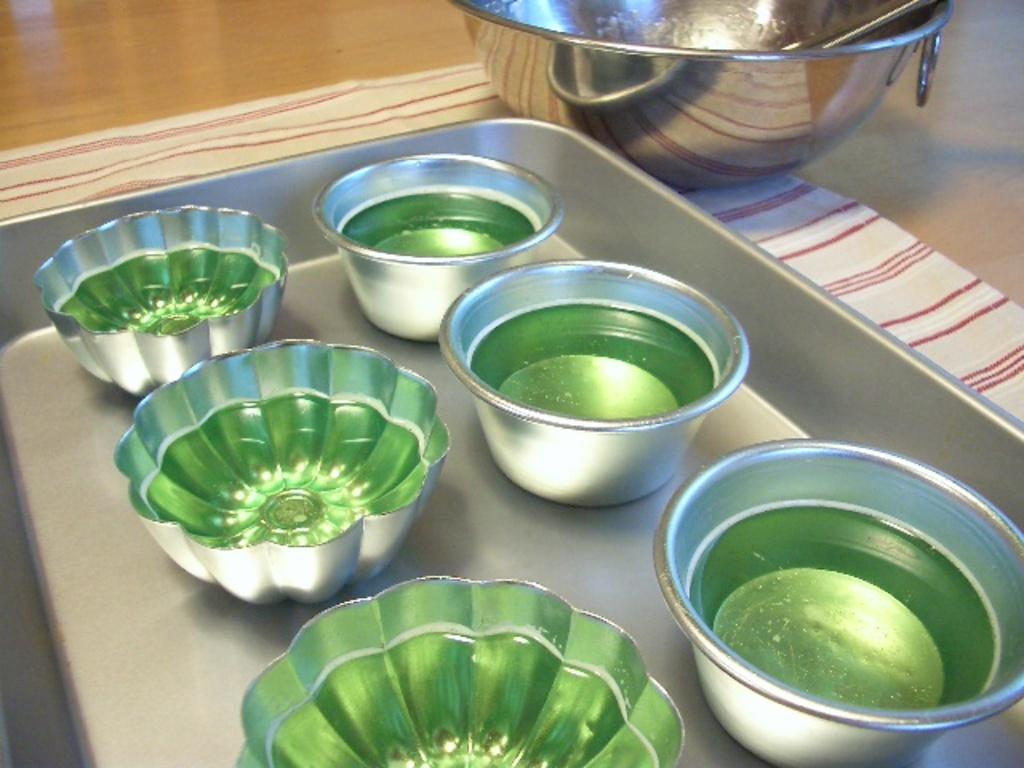What piece of furniture is present in the image? There is a table in the image. What is placed on the table? There is a towel and a metal tray on the table. What is the metal tray used for? The metal tray contains bowls. Can you describe the contents of one of the bowls? There is a bowl with a spoon on it. What type of mailbox is visible in the image? There is no mailbox present in the image. What motion is being performed by the rod in the image? There is no rod present in the image. 